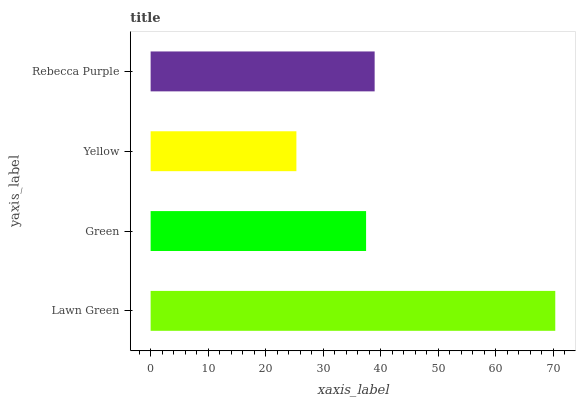Is Yellow the minimum?
Answer yes or no. Yes. Is Lawn Green the maximum?
Answer yes or no. Yes. Is Green the minimum?
Answer yes or no. No. Is Green the maximum?
Answer yes or no. No. Is Lawn Green greater than Green?
Answer yes or no. Yes. Is Green less than Lawn Green?
Answer yes or no. Yes. Is Green greater than Lawn Green?
Answer yes or no. No. Is Lawn Green less than Green?
Answer yes or no. No. Is Rebecca Purple the high median?
Answer yes or no. Yes. Is Green the low median?
Answer yes or no. Yes. Is Lawn Green the high median?
Answer yes or no. No. Is Lawn Green the low median?
Answer yes or no. No. 